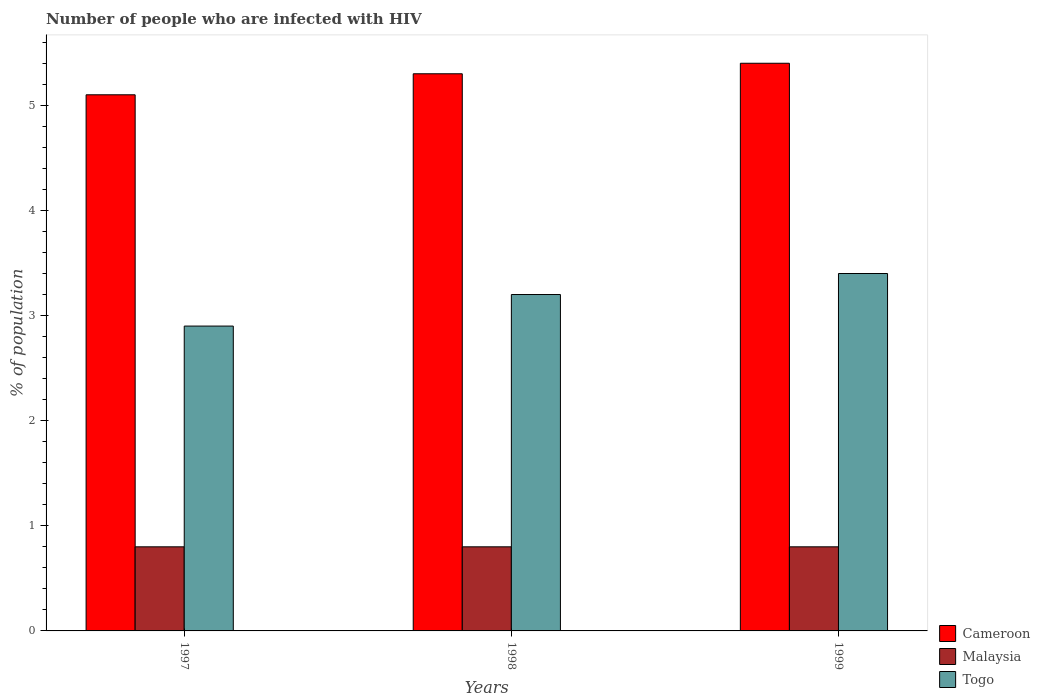Are the number of bars on each tick of the X-axis equal?
Provide a succinct answer. Yes. How many bars are there on the 3rd tick from the left?
Give a very brief answer. 3. How many bars are there on the 1st tick from the right?
Your answer should be compact. 3. In how many cases, is the number of bars for a given year not equal to the number of legend labels?
Give a very brief answer. 0. What is the percentage of HIV infected population in in Togo in 1999?
Provide a short and direct response. 3.4. Across all years, what is the maximum percentage of HIV infected population in in Togo?
Ensure brevity in your answer.  3.4. In which year was the percentage of HIV infected population in in Togo maximum?
Your answer should be very brief. 1999. In which year was the percentage of HIV infected population in in Togo minimum?
Offer a very short reply. 1997. What is the total percentage of HIV infected population in in Togo in the graph?
Make the answer very short. 9.5. What is the difference between the percentage of HIV infected population in in Togo in 1998 and the percentage of HIV infected population in in Cameroon in 1997?
Offer a very short reply. -1.9. What is the average percentage of HIV infected population in in Togo per year?
Give a very brief answer. 3.17. In the year 1998, what is the difference between the percentage of HIV infected population in in Cameroon and percentage of HIV infected population in in Togo?
Keep it short and to the point. 2.1. In how many years, is the percentage of HIV infected population in in Togo greater than 3 %?
Offer a terse response. 2. What is the ratio of the percentage of HIV infected population in in Cameroon in 1997 to that in 1999?
Offer a terse response. 0.94. What is the difference between the highest and the second highest percentage of HIV infected population in in Malaysia?
Your response must be concise. 0. What is the difference between the highest and the lowest percentage of HIV infected population in in Togo?
Provide a short and direct response. 0.5. In how many years, is the percentage of HIV infected population in in Cameroon greater than the average percentage of HIV infected population in in Cameroon taken over all years?
Ensure brevity in your answer.  2. What does the 1st bar from the left in 1999 represents?
Provide a short and direct response. Cameroon. What does the 2nd bar from the right in 1997 represents?
Offer a very short reply. Malaysia. How many years are there in the graph?
Provide a succinct answer. 3. What is the difference between two consecutive major ticks on the Y-axis?
Offer a terse response. 1. Are the values on the major ticks of Y-axis written in scientific E-notation?
Make the answer very short. No. Where does the legend appear in the graph?
Your response must be concise. Bottom right. What is the title of the graph?
Your answer should be very brief. Number of people who are infected with HIV. What is the label or title of the X-axis?
Your answer should be very brief. Years. What is the label or title of the Y-axis?
Your answer should be compact. % of population. What is the % of population in Cameroon in 1997?
Make the answer very short. 5.1. What is the % of population in Malaysia in 1997?
Make the answer very short. 0.8. What is the % of population in Malaysia in 1998?
Offer a terse response. 0.8. Across all years, what is the maximum % of population of Malaysia?
Keep it short and to the point. 0.8. Across all years, what is the maximum % of population of Togo?
Offer a terse response. 3.4. Across all years, what is the minimum % of population of Malaysia?
Ensure brevity in your answer.  0.8. Across all years, what is the minimum % of population of Togo?
Make the answer very short. 2.9. What is the total % of population in Cameroon in the graph?
Give a very brief answer. 15.8. What is the total % of population in Malaysia in the graph?
Make the answer very short. 2.4. What is the total % of population in Togo in the graph?
Make the answer very short. 9.5. What is the difference between the % of population of Cameroon in 1997 and that in 1998?
Provide a short and direct response. -0.2. What is the difference between the % of population in Malaysia in 1997 and that in 1998?
Make the answer very short. 0. What is the difference between the % of population in Togo in 1997 and that in 1998?
Keep it short and to the point. -0.3. What is the difference between the % of population in Cameroon in 1997 and that in 1999?
Make the answer very short. -0.3. What is the difference between the % of population in Malaysia in 1997 and that in 1999?
Your answer should be compact. 0. What is the difference between the % of population of Togo in 1997 and that in 1999?
Your answer should be compact. -0.5. What is the difference between the % of population in Cameroon in 1998 and that in 1999?
Offer a very short reply. -0.1. What is the difference between the % of population of Cameroon in 1997 and the % of population of Togo in 1998?
Keep it short and to the point. 1.9. What is the difference between the % of population in Cameroon in 1997 and the % of population in Togo in 1999?
Provide a short and direct response. 1.7. What is the difference between the % of population of Malaysia in 1997 and the % of population of Togo in 1999?
Keep it short and to the point. -2.6. What is the difference between the % of population in Cameroon in 1998 and the % of population in Togo in 1999?
Your answer should be very brief. 1.9. What is the average % of population of Cameroon per year?
Provide a succinct answer. 5.27. What is the average % of population of Togo per year?
Ensure brevity in your answer.  3.17. In the year 1997, what is the difference between the % of population in Cameroon and % of population in Malaysia?
Ensure brevity in your answer.  4.3. In the year 1997, what is the difference between the % of population of Cameroon and % of population of Togo?
Ensure brevity in your answer.  2.2. In the year 1997, what is the difference between the % of population in Malaysia and % of population in Togo?
Offer a very short reply. -2.1. In the year 1999, what is the difference between the % of population in Cameroon and % of population in Togo?
Provide a short and direct response. 2. In the year 1999, what is the difference between the % of population in Malaysia and % of population in Togo?
Your response must be concise. -2.6. What is the ratio of the % of population of Cameroon in 1997 to that in 1998?
Give a very brief answer. 0.96. What is the ratio of the % of population of Malaysia in 1997 to that in 1998?
Make the answer very short. 1. What is the ratio of the % of population of Togo in 1997 to that in 1998?
Ensure brevity in your answer.  0.91. What is the ratio of the % of population of Cameroon in 1997 to that in 1999?
Ensure brevity in your answer.  0.94. What is the ratio of the % of population in Togo in 1997 to that in 1999?
Your response must be concise. 0.85. What is the ratio of the % of population in Cameroon in 1998 to that in 1999?
Offer a terse response. 0.98. What is the ratio of the % of population of Malaysia in 1998 to that in 1999?
Make the answer very short. 1. What is the ratio of the % of population in Togo in 1998 to that in 1999?
Offer a very short reply. 0.94. What is the difference between the highest and the second highest % of population of Malaysia?
Provide a succinct answer. 0. What is the difference between the highest and the second highest % of population in Togo?
Make the answer very short. 0.2. What is the difference between the highest and the lowest % of population of Cameroon?
Your answer should be compact. 0.3. What is the difference between the highest and the lowest % of population in Malaysia?
Ensure brevity in your answer.  0. What is the difference between the highest and the lowest % of population of Togo?
Give a very brief answer. 0.5. 